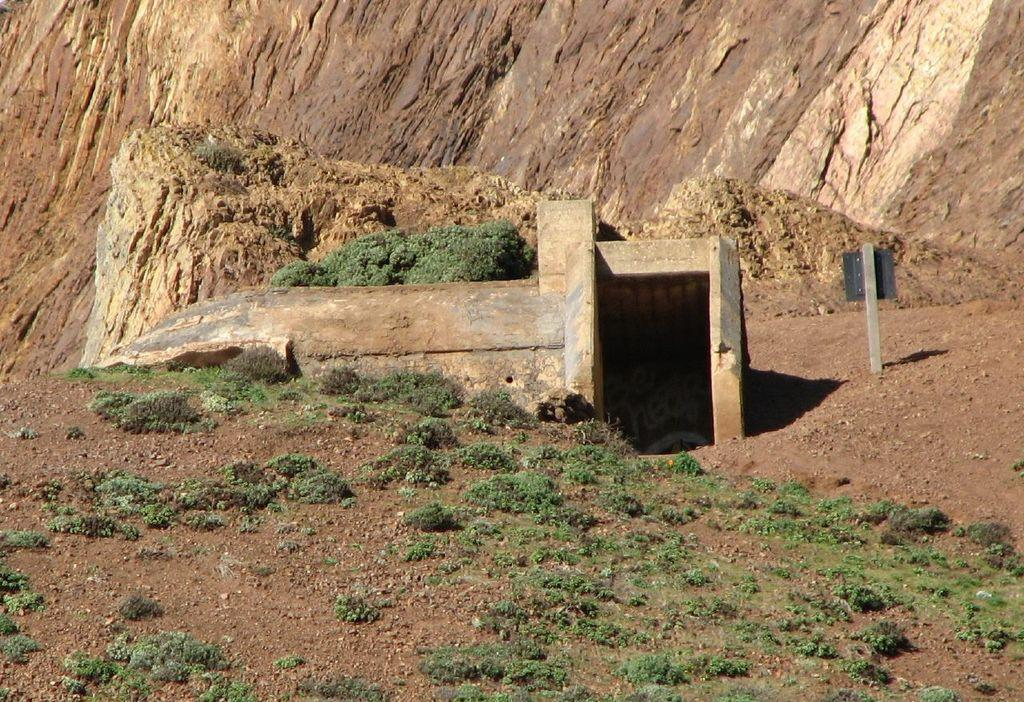What celestial bodies can be seen in the image? There are planets visible in the image. What type of natural feature is present in the image? There is a hill in the image. How would you describe the overall appearance of the image? The image has an architecture-like appearance. How many bikes can be seen parked near the hill in the image? There are no bikes present in the image. What type of flower is growing near the planets in the image? There are no flowers present in the image. 